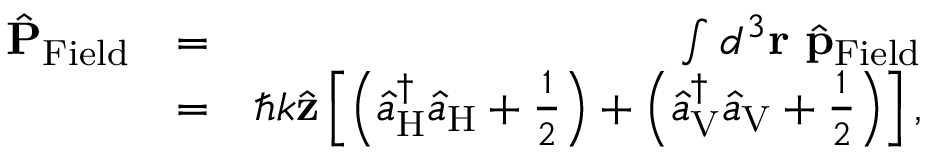<formula> <loc_0><loc_0><loc_500><loc_500>\begin{array} { r l r } { \hat { P } _ { F i e l d } } & { = } & { \int d ^ { 3 } { r } \ \hat { p } _ { F i e l d } } \\ & { = } & { \hbar { k } \hat { z } \left [ \left ( \hat { a } _ { H } ^ { \dagger } \hat { a } _ { H } + \frac { 1 } { 2 } \right ) + \left ( \hat { a } _ { V } ^ { \dagger } \hat { a } _ { V } + \frac { 1 } { 2 } \right ) \right ] , } \end{array}</formula> 